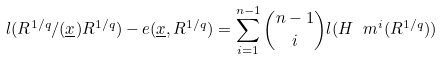<formula> <loc_0><loc_0><loc_500><loc_500>l ( R ^ { 1 / q } / ( \underline { x } ) R ^ { 1 / q } ) - e ( \underline { x } , R ^ { 1 / q } ) = \sum _ { i = 1 } ^ { n - 1 } \binom { n - 1 } { i } l ( H _ { \ } m ^ { i } ( R ^ { 1 / q } ) )</formula> 